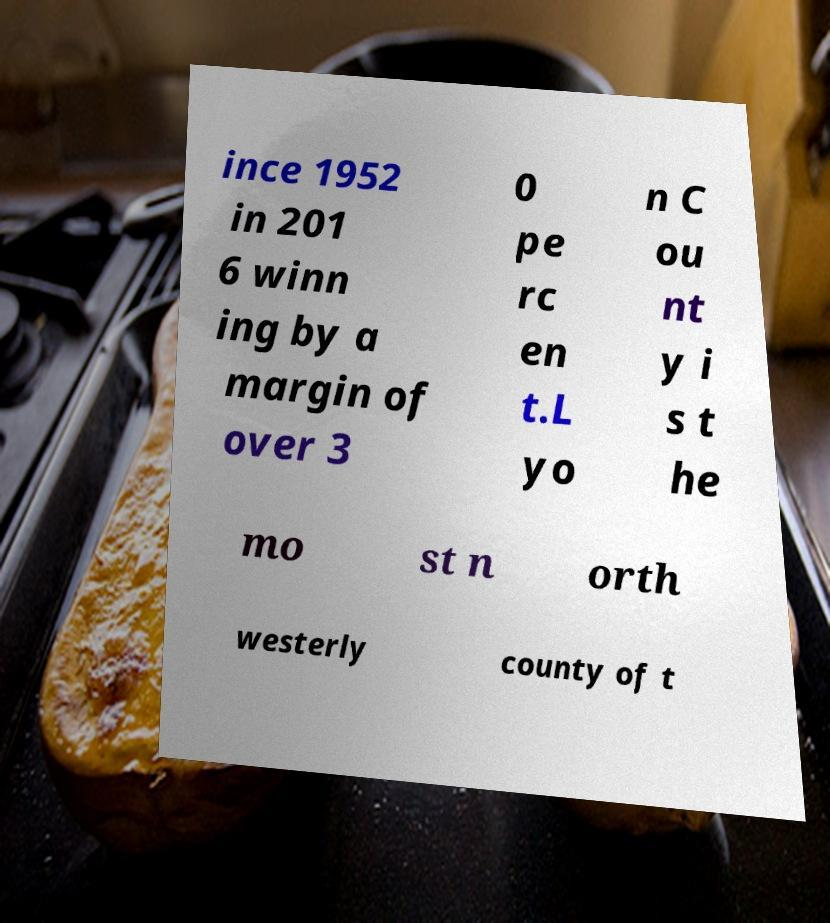Can you accurately transcribe the text from the provided image for me? ince 1952 in 201 6 winn ing by a margin of over 3 0 pe rc en t.L yo n C ou nt y i s t he mo st n orth westerly county of t 